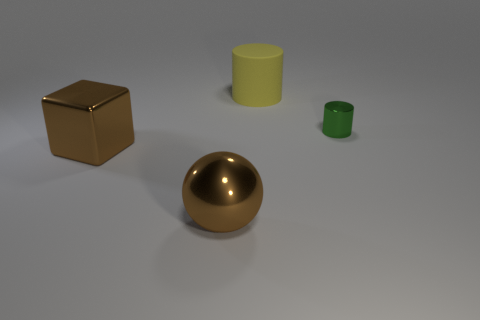Subtract all gray cylinders. Subtract all cyan blocks. How many cylinders are left? 2 Add 3 cylinders. How many objects exist? 7 Subtract all spheres. How many objects are left? 3 Add 3 large shiny cubes. How many large shiny cubes exist? 4 Subtract 0 cyan balls. How many objects are left? 4 Subtract all tiny cylinders. Subtract all small yellow metallic balls. How many objects are left? 3 Add 2 shiny spheres. How many shiny spheres are left? 3 